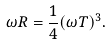Convert formula to latex. <formula><loc_0><loc_0><loc_500><loc_500>\omega R = \frac { 1 } { 4 } ( \omega T ) ^ { 3 } .</formula> 